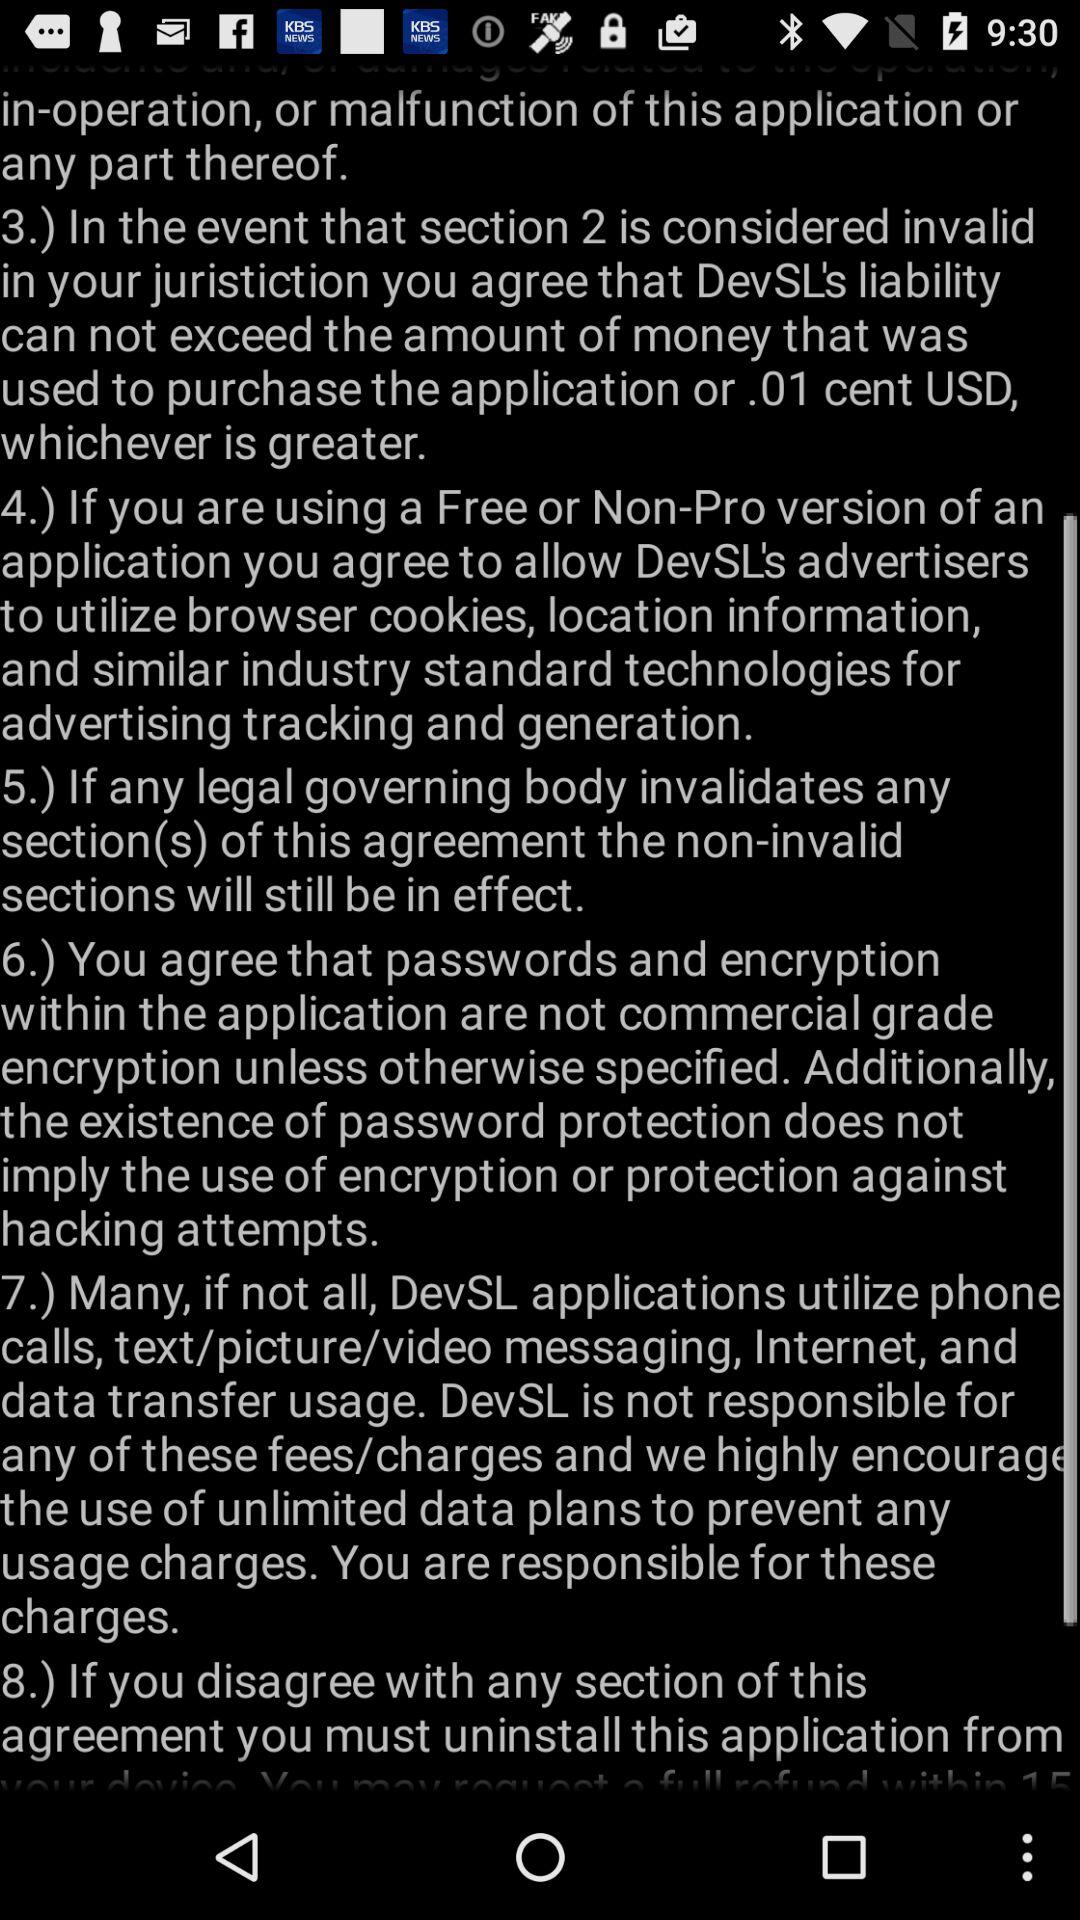How many sections are there in this agreement?
Answer the question using a single word or phrase. 8 